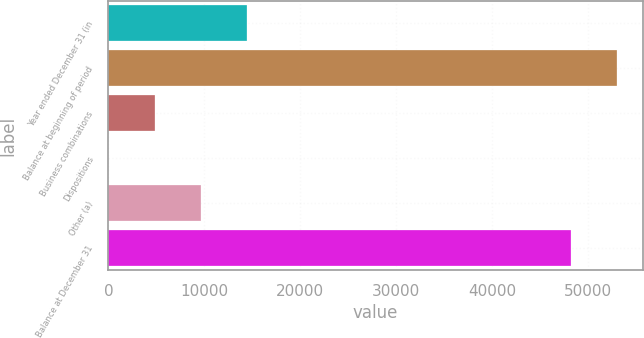Convert chart to OTSL. <chart><loc_0><loc_0><loc_500><loc_500><bar_chart><fcel>Year ended December 31 (in<fcel>Balance at beginning of period<fcel>Business combinations<fcel>Dispositions<fcel>Other (a)<fcel>Balance at December 31<nl><fcel>14459.2<fcel>52993.4<fcel>4822.4<fcel>4<fcel>9640.8<fcel>48175<nl></chart> 